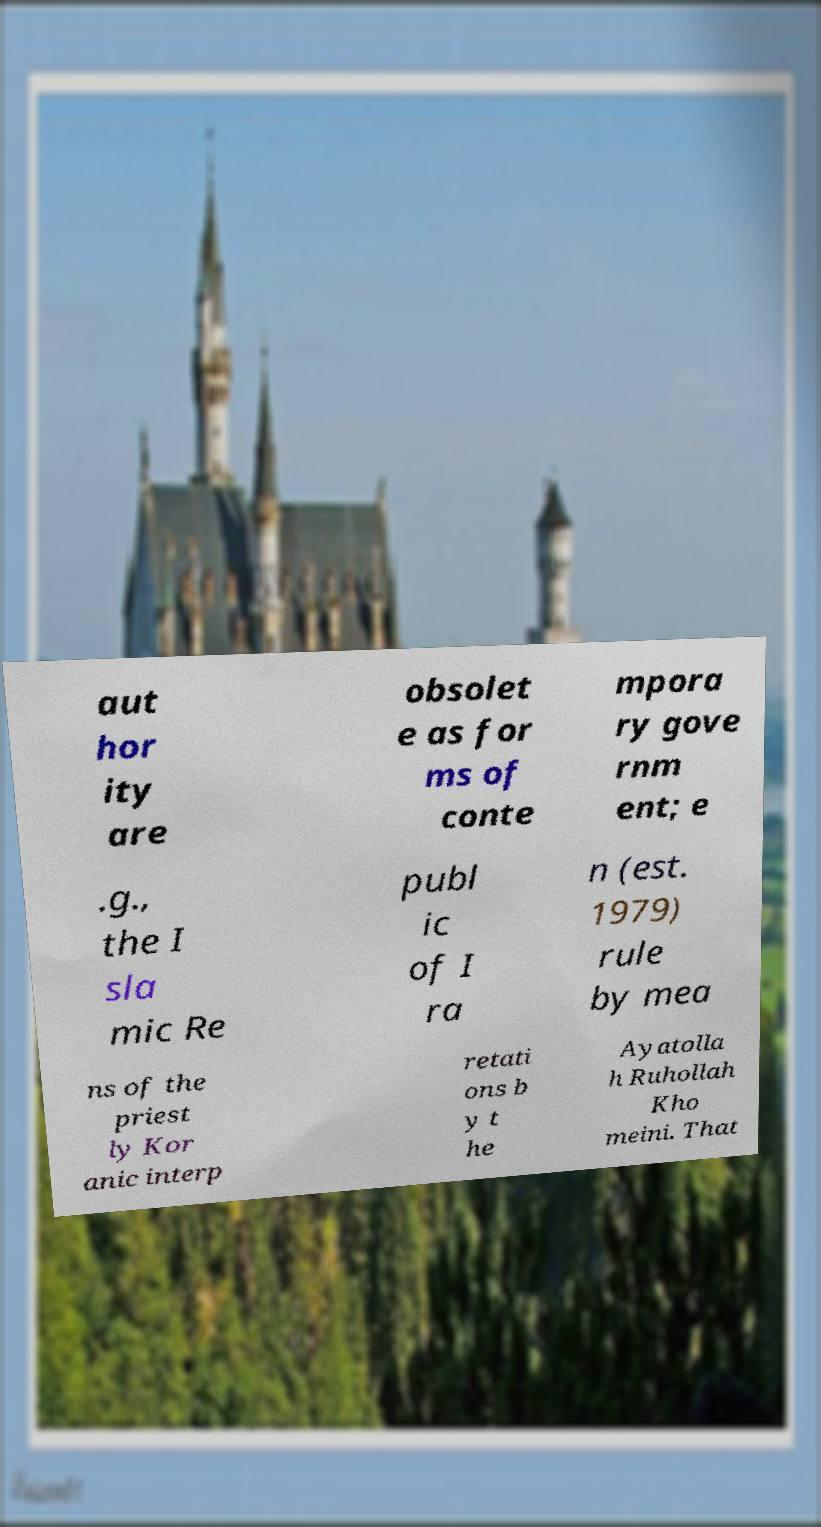Could you assist in decoding the text presented in this image and type it out clearly? aut hor ity are obsolet e as for ms of conte mpora ry gove rnm ent; e .g., the I sla mic Re publ ic of I ra n (est. 1979) rule by mea ns of the priest ly Kor anic interp retati ons b y t he Ayatolla h Ruhollah Kho meini. That 